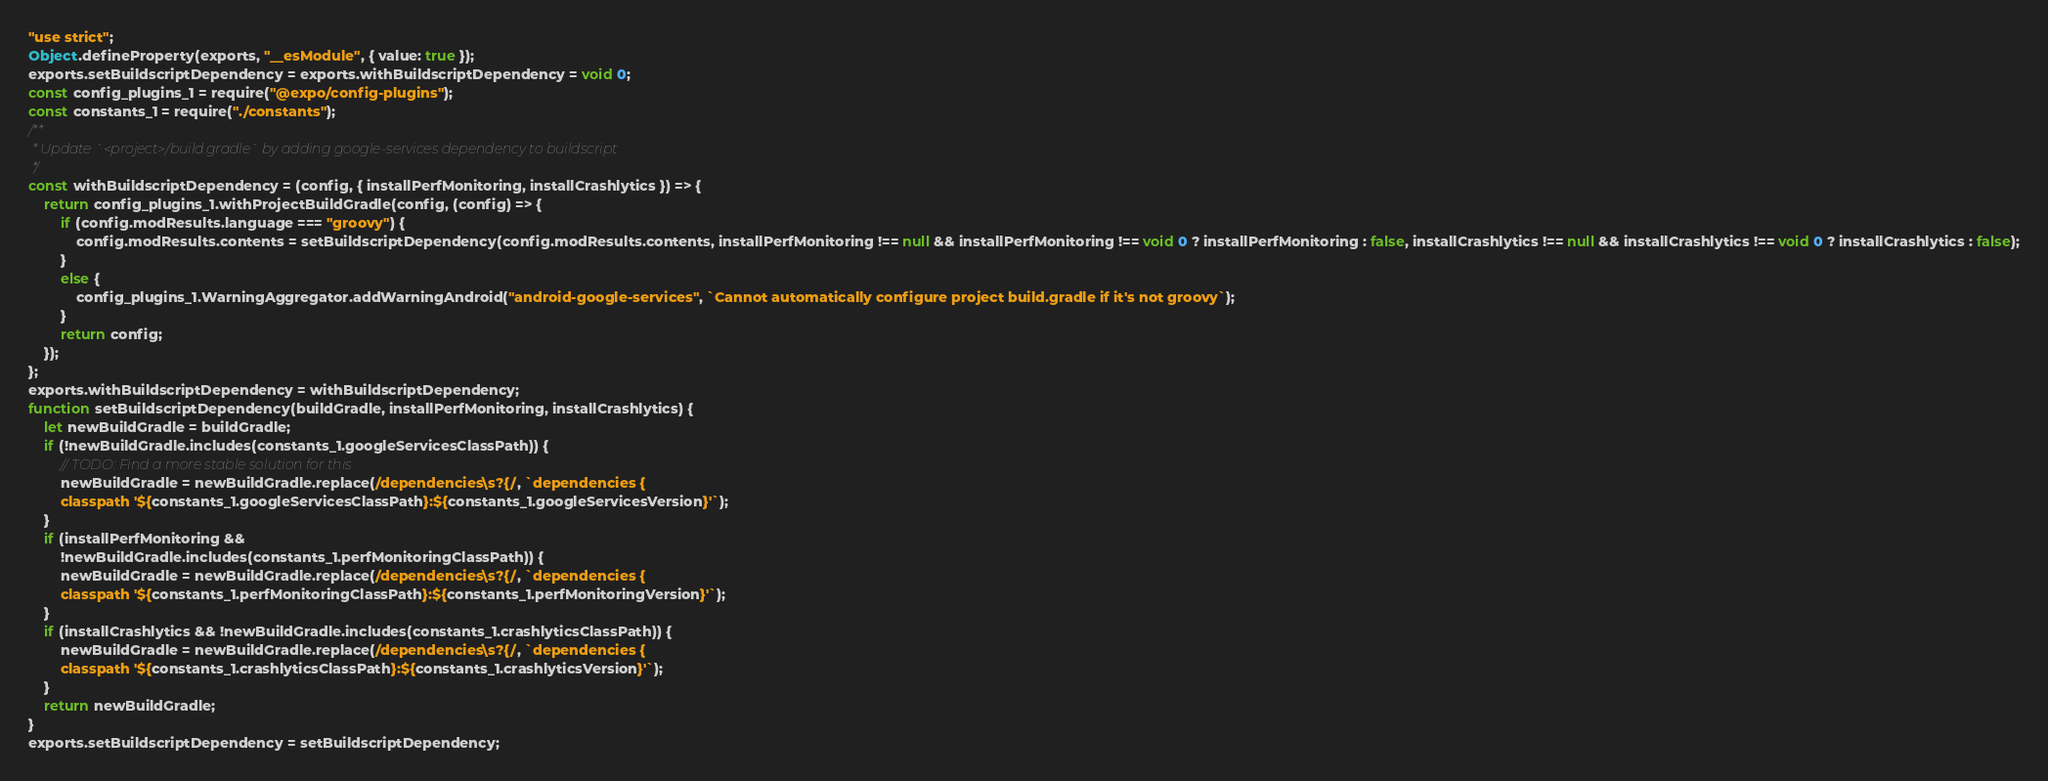<code> <loc_0><loc_0><loc_500><loc_500><_JavaScript_>"use strict";
Object.defineProperty(exports, "__esModule", { value: true });
exports.setBuildscriptDependency = exports.withBuildscriptDependency = void 0;
const config_plugins_1 = require("@expo/config-plugins");
const constants_1 = require("./constants");
/**
 * Update `<project>/build.gradle` by adding google-services dependency to buildscript
 */
const withBuildscriptDependency = (config, { installPerfMonitoring, installCrashlytics }) => {
    return config_plugins_1.withProjectBuildGradle(config, (config) => {
        if (config.modResults.language === "groovy") {
            config.modResults.contents = setBuildscriptDependency(config.modResults.contents, installPerfMonitoring !== null && installPerfMonitoring !== void 0 ? installPerfMonitoring : false, installCrashlytics !== null && installCrashlytics !== void 0 ? installCrashlytics : false);
        }
        else {
            config_plugins_1.WarningAggregator.addWarningAndroid("android-google-services", `Cannot automatically configure project build.gradle if it's not groovy`);
        }
        return config;
    });
};
exports.withBuildscriptDependency = withBuildscriptDependency;
function setBuildscriptDependency(buildGradle, installPerfMonitoring, installCrashlytics) {
    let newBuildGradle = buildGradle;
    if (!newBuildGradle.includes(constants_1.googleServicesClassPath)) {
        // TODO: Find a more stable solution for this
        newBuildGradle = newBuildGradle.replace(/dependencies\s?{/, `dependencies {
        classpath '${constants_1.googleServicesClassPath}:${constants_1.googleServicesVersion}'`);
    }
    if (installPerfMonitoring &&
        !newBuildGradle.includes(constants_1.perfMonitoringClassPath)) {
        newBuildGradle = newBuildGradle.replace(/dependencies\s?{/, `dependencies {
        classpath '${constants_1.perfMonitoringClassPath}:${constants_1.perfMonitoringVersion}'`);
    }
    if (installCrashlytics && !newBuildGradle.includes(constants_1.crashlyticsClassPath)) {
        newBuildGradle = newBuildGradle.replace(/dependencies\s?{/, `dependencies {
        classpath '${constants_1.crashlyticsClassPath}:${constants_1.crashlyticsVersion}'`);
    }
    return newBuildGradle;
}
exports.setBuildscriptDependency = setBuildscriptDependency;
</code> 